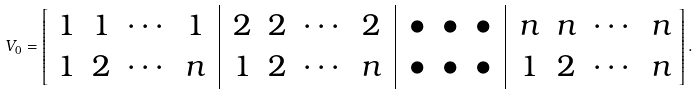Convert formula to latex. <formula><loc_0><loc_0><loc_500><loc_500>V _ { 0 } = \left [ \begin{array} { c c c c | c c c c | c c c | c c c c } 1 & 1 & \cdots & 1 \, & \, 2 & 2 & \cdots & 2 \, & \, \bullet & \bullet & \bullet \, & \, n & n & \cdots & n \\ 1 & 2 & \cdots & n \, & \, 1 & 2 & \cdots & n \, & \, \bullet & \bullet & \bullet \, & \, 1 & 2 & \cdots & n \end{array} \right ] .</formula> 